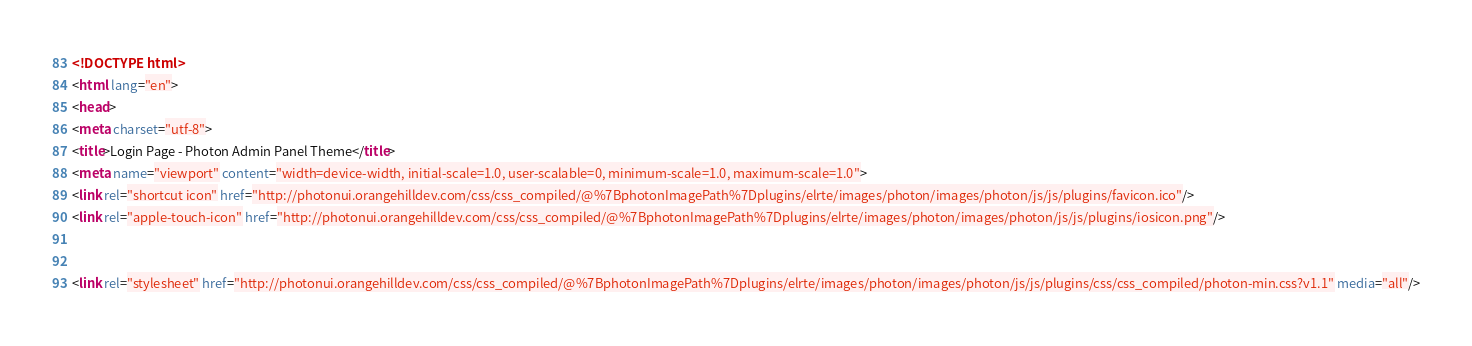Convert code to text. <code><loc_0><loc_0><loc_500><loc_500><_HTML_><!DOCTYPE html>
<html lang="en">
<head>
<meta charset="utf-8">
<title>Login Page - Photon Admin Panel Theme</title>
<meta name="viewport" content="width=device-width, initial-scale=1.0, user-scalable=0, minimum-scale=1.0, maximum-scale=1.0">
<link rel="shortcut icon" href="http://photonui.orangehilldev.com/css/css_compiled/@%7BphotonImagePath%7Dplugins/elrte/images/photon/images/photon/js/js/plugins/favicon.ico"/>
<link rel="apple-touch-icon" href="http://photonui.orangehilldev.com/css/css_compiled/@%7BphotonImagePath%7Dplugins/elrte/images/photon/images/photon/js/js/plugins/iosicon.png"/>
 
   
<link rel="stylesheet" href="http://photonui.orangehilldev.com/css/css_compiled/@%7BphotonImagePath%7Dplugins/elrte/images/photon/images/photon/js/js/plugins/css/css_compiled/photon-min.css?v1.1" media="all"/></code> 